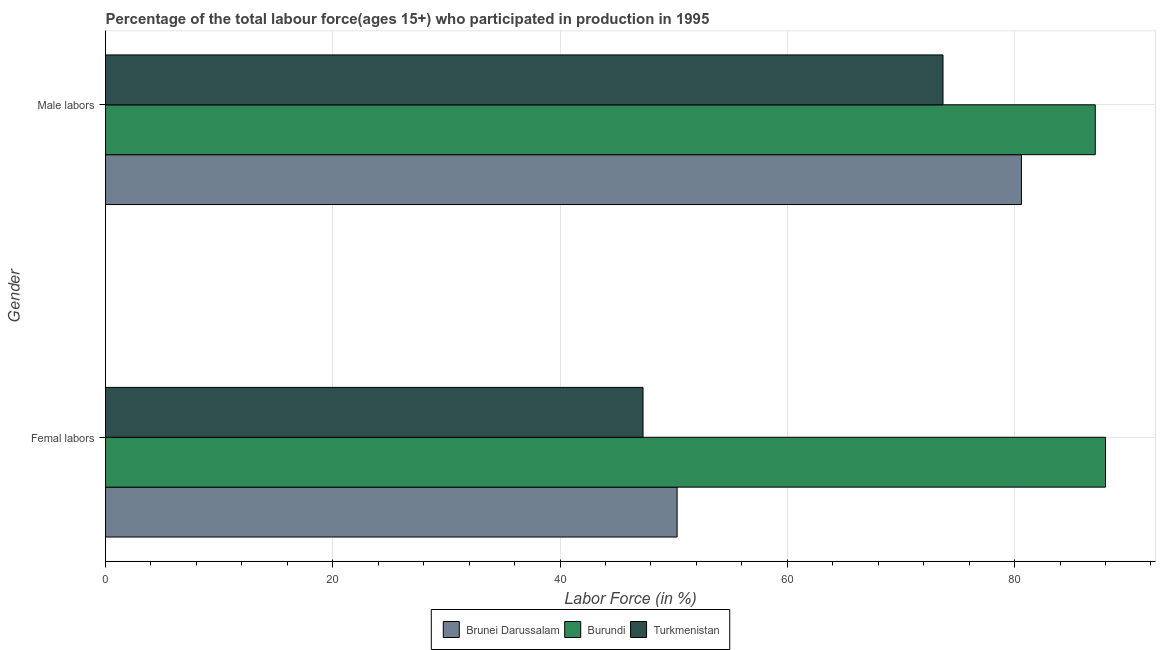How many bars are there on the 1st tick from the top?
Your answer should be compact. 3. What is the label of the 1st group of bars from the top?
Give a very brief answer. Male labors. What is the percentage of male labour force in Brunei Darussalam?
Provide a succinct answer. 80.6. Across all countries, what is the maximum percentage of female labor force?
Your answer should be very brief. 88. Across all countries, what is the minimum percentage of female labor force?
Make the answer very short. 47.3. In which country was the percentage of female labor force maximum?
Your response must be concise. Burundi. In which country was the percentage of female labor force minimum?
Offer a very short reply. Turkmenistan. What is the total percentage of female labor force in the graph?
Provide a short and direct response. 185.6. What is the difference between the percentage of male labour force in Turkmenistan and that in Burundi?
Your answer should be very brief. -13.4. What is the difference between the percentage of male labour force in Turkmenistan and the percentage of female labor force in Burundi?
Your answer should be very brief. -14.3. What is the average percentage of female labor force per country?
Your response must be concise. 61.87. What is the difference between the percentage of male labour force and percentage of female labor force in Burundi?
Give a very brief answer. -0.9. What is the ratio of the percentage of female labor force in Brunei Darussalam to that in Turkmenistan?
Keep it short and to the point. 1.06. What does the 2nd bar from the top in Male labors represents?
Your answer should be compact. Burundi. What does the 1st bar from the bottom in Femal labors represents?
Your response must be concise. Brunei Darussalam. How many bars are there?
Make the answer very short. 6. Are all the bars in the graph horizontal?
Give a very brief answer. Yes. How many countries are there in the graph?
Provide a succinct answer. 3. What is the difference between two consecutive major ticks on the X-axis?
Your response must be concise. 20. Are the values on the major ticks of X-axis written in scientific E-notation?
Offer a very short reply. No. Does the graph contain any zero values?
Make the answer very short. No. How many legend labels are there?
Ensure brevity in your answer.  3. How are the legend labels stacked?
Your answer should be very brief. Horizontal. What is the title of the graph?
Ensure brevity in your answer.  Percentage of the total labour force(ages 15+) who participated in production in 1995. What is the Labor Force (in %) in Brunei Darussalam in Femal labors?
Make the answer very short. 50.3. What is the Labor Force (in %) of Turkmenistan in Femal labors?
Offer a terse response. 47.3. What is the Labor Force (in %) of Brunei Darussalam in Male labors?
Your answer should be very brief. 80.6. What is the Labor Force (in %) of Burundi in Male labors?
Give a very brief answer. 87.1. What is the Labor Force (in %) of Turkmenistan in Male labors?
Give a very brief answer. 73.7. Across all Gender, what is the maximum Labor Force (in %) in Brunei Darussalam?
Provide a short and direct response. 80.6. Across all Gender, what is the maximum Labor Force (in %) of Burundi?
Offer a very short reply. 88. Across all Gender, what is the maximum Labor Force (in %) in Turkmenistan?
Give a very brief answer. 73.7. Across all Gender, what is the minimum Labor Force (in %) in Brunei Darussalam?
Provide a succinct answer. 50.3. Across all Gender, what is the minimum Labor Force (in %) in Burundi?
Make the answer very short. 87.1. Across all Gender, what is the minimum Labor Force (in %) of Turkmenistan?
Provide a short and direct response. 47.3. What is the total Labor Force (in %) of Brunei Darussalam in the graph?
Ensure brevity in your answer.  130.9. What is the total Labor Force (in %) of Burundi in the graph?
Your response must be concise. 175.1. What is the total Labor Force (in %) in Turkmenistan in the graph?
Give a very brief answer. 121. What is the difference between the Labor Force (in %) in Brunei Darussalam in Femal labors and that in Male labors?
Keep it short and to the point. -30.3. What is the difference between the Labor Force (in %) of Burundi in Femal labors and that in Male labors?
Provide a short and direct response. 0.9. What is the difference between the Labor Force (in %) in Turkmenistan in Femal labors and that in Male labors?
Provide a succinct answer. -26.4. What is the difference between the Labor Force (in %) in Brunei Darussalam in Femal labors and the Labor Force (in %) in Burundi in Male labors?
Provide a succinct answer. -36.8. What is the difference between the Labor Force (in %) in Brunei Darussalam in Femal labors and the Labor Force (in %) in Turkmenistan in Male labors?
Your response must be concise. -23.4. What is the average Labor Force (in %) of Brunei Darussalam per Gender?
Your answer should be very brief. 65.45. What is the average Labor Force (in %) in Burundi per Gender?
Your answer should be very brief. 87.55. What is the average Labor Force (in %) in Turkmenistan per Gender?
Provide a succinct answer. 60.5. What is the difference between the Labor Force (in %) of Brunei Darussalam and Labor Force (in %) of Burundi in Femal labors?
Provide a succinct answer. -37.7. What is the difference between the Labor Force (in %) in Burundi and Labor Force (in %) in Turkmenistan in Femal labors?
Offer a terse response. 40.7. What is the difference between the Labor Force (in %) of Brunei Darussalam and Labor Force (in %) of Turkmenistan in Male labors?
Give a very brief answer. 6.9. What is the difference between the Labor Force (in %) in Burundi and Labor Force (in %) in Turkmenistan in Male labors?
Keep it short and to the point. 13.4. What is the ratio of the Labor Force (in %) in Brunei Darussalam in Femal labors to that in Male labors?
Your answer should be compact. 0.62. What is the ratio of the Labor Force (in %) in Burundi in Femal labors to that in Male labors?
Ensure brevity in your answer.  1.01. What is the ratio of the Labor Force (in %) of Turkmenistan in Femal labors to that in Male labors?
Offer a very short reply. 0.64. What is the difference between the highest and the second highest Labor Force (in %) of Brunei Darussalam?
Ensure brevity in your answer.  30.3. What is the difference between the highest and the second highest Labor Force (in %) in Burundi?
Offer a very short reply. 0.9. What is the difference between the highest and the second highest Labor Force (in %) of Turkmenistan?
Provide a short and direct response. 26.4. What is the difference between the highest and the lowest Labor Force (in %) of Brunei Darussalam?
Your answer should be very brief. 30.3. What is the difference between the highest and the lowest Labor Force (in %) in Burundi?
Provide a short and direct response. 0.9. What is the difference between the highest and the lowest Labor Force (in %) in Turkmenistan?
Your answer should be compact. 26.4. 